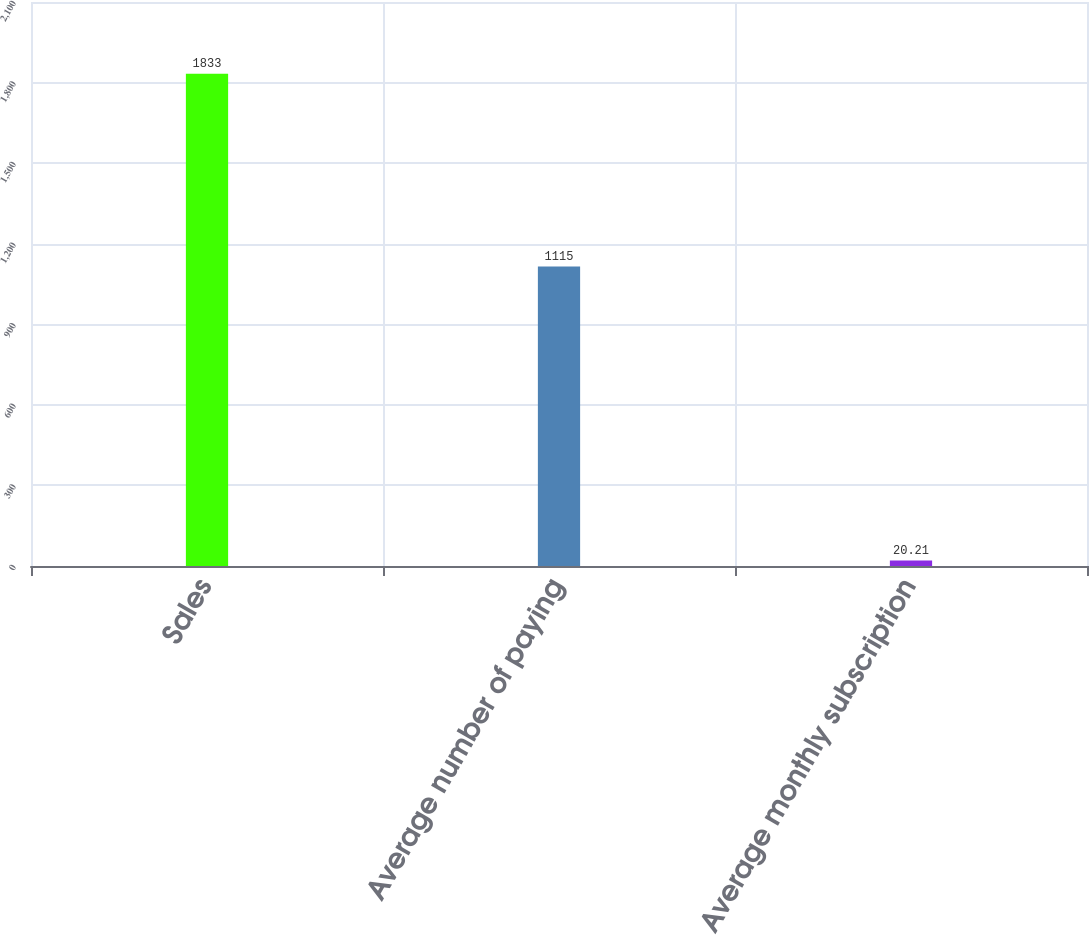Convert chart. <chart><loc_0><loc_0><loc_500><loc_500><bar_chart><fcel>Sales<fcel>Average number of paying<fcel>Average monthly subscription<nl><fcel>1833<fcel>1115<fcel>20.21<nl></chart> 